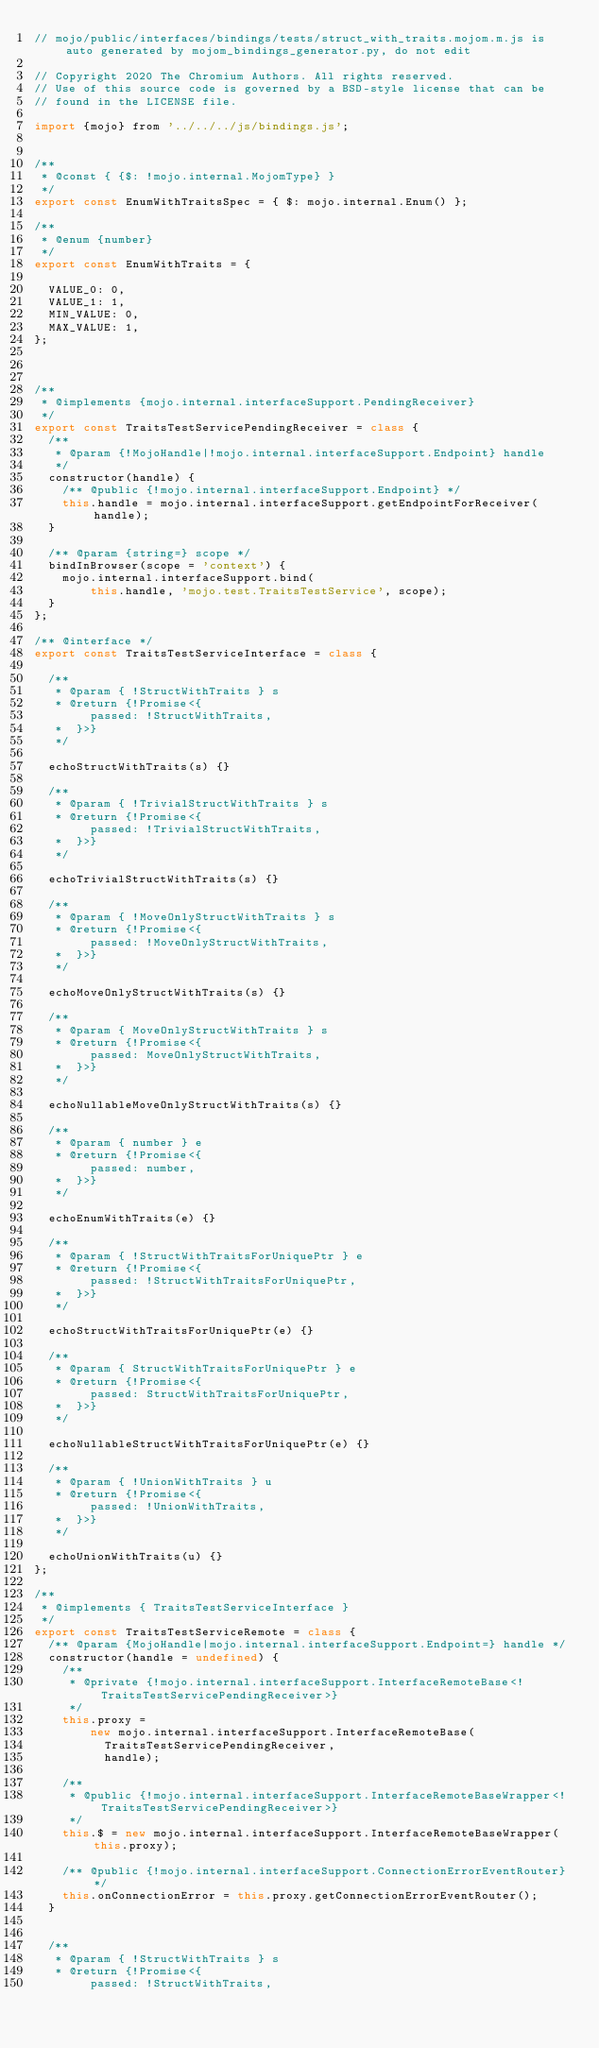<code> <loc_0><loc_0><loc_500><loc_500><_JavaScript_>// mojo/public/interfaces/bindings/tests/struct_with_traits.mojom.m.js is auto generated by mojom_bindings_generator.py, do not edit

// Copyright 2020 The Chromium Authors. All rights reserved.
// Use of this source code is governed by a BSD-style license that can be
// found in the LICENSE file.

import {mojo} from '../../../js/bindings.js';


/**
 * @const { {$: !mojo.internal.MojomType} }
 */
export const EnumWithTraitsSpec = { $: mojo.internal.Enum() };

/**
 * @enum {number}
 */
export const EnumWithTraits = {
  
  VALUE_0: 0,
  VALUE_1: 1,
  MIN_VALUE: 0,
  MAX_VALUE: 1,
};



/**
 * @implements {mojo.internal.interfaceSupport.PendingReceiver}
 */
export const TraitsTestServicePendingReceiver = class {
  /**
   * @param {!MojoHandle|!mojo.internal.interfaceSupport.Endpoint} handle
   */
  constructor(handle) {
    /** @public {!mojo.internal.interfaceSupport.Endpoint} */
    this.handle = mojo.internal.interfaceSupport.getEndpointForReceiver(handle);
  }

  /** @param {string=} scope */
  bindInBrowser(scope = 'context') {
    mojo.internal.interfaceSupport.bind(
        this.handle, 'mojo.test.TraitsTestService', scope);
  }
};

/** @interface */
export const TraitsTestServiceInterface = class {
  
  /**
   * @param { !StructWithTraits } s
   * @return {!Promise<{
        passed: !StructWithTraits,
   *  }>}
   */

  echoStructWithTraits(s) {}
  
  /**
   * @param { !TrivialStructWithTraits } s
   * @return {!Promise<{
        passed: !TrivialStructWithTraits,
   *  }>}
   */

  echoTrivialStructWithTraits(s) {}
  
  /**
   * @param { !MoveOnlyStructWithTraits } s
   * @return {!Promise<{
        passed: !MoveOnlyStructWithTraits,
   *  }>}
   */

  echoMoveOnlyStructWithTraits(s) {}
  
  /**
   * @param { MoveOnlyStructWithTraits } s
   * @return {!Promise<{
        passed: MoveOnlyStructWithTraits,
   *  }>}
   */

  echoNullableMoveOnlyStructWithTraits(s) {}
  
  /**
   * @param { number } e
   * @return {!Promise<{
        passed: number,
   *  }>}
   */

  echoEnumWithTraits(e) {}
  
  /**
   * @param { !StructWithTraitsForUniquePtr } e
   * @return {!Promise<{
        passed: !StructWithTraitsForUniquePtr,
   *  }>}
   */

  echoStructWithTraitsForUniquePtr(e) {}
  
  /**
   * @param { StructWithTraitsForUniquePtr } e
   * @return {!Promise<{
        passed: StructWithTraitsForUniquePtr,
   *  }>}
   */

  echoNullableStructWithTraitsForUniquePtr(e) {}
  
  /**
   * @param { !UnionWithTraits } u
   * @return {!Promise<{
        passed: !UnionWithTraits,
   *  }>}
   */

  echoUnionWithTraits(u) {}
};

/**
 * @implements { TraitsTestServiceInterface }
 */
export const TraitsTestServiceRemote = class {
  /** @param {MojoHandle|mojo.internal.interfaceSupport.Endpoint=} handle */
  constructor(handle = undefined) {
    /**
     * @private {!mojo.internal.interfaceSupport.InterfaceRemoteBase<!TraitsTestServicePendingReceiver>}
     */
    this.proxy =
        new mojo.internal.interfaceSupport.InterfaceRemoteBase(
          TraitsTestServicePendingReceiver,
          handle);

    /**
     * @public {!mojo.internal.interfaceSupport.InterfaceRemoteBaseWrapper<!TraitsTestServicePendingReceiver>}
     */
    this.$ = new mojo.internal.interfaceSupport.InterfaceRemoteBaseWrapper(this.proxy);

    /** @public {!mojo.internal.interfaceSupport.ConnectionErrorEventRouter} */
    this.onConnectionError = this.proxy.getConnectionErrorEventRouter();
  }

  
  /**
   * @param { !StructWithTraits } s
   * @return {!Promise<{
        passed: !StructWithTraits,</code> 